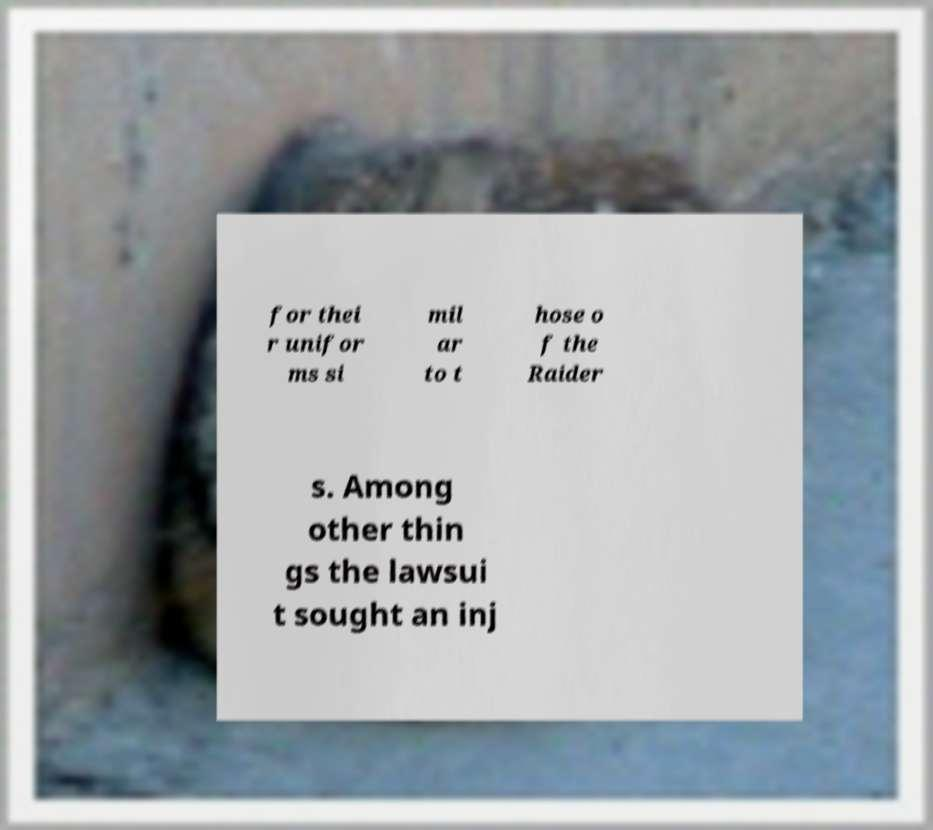For documentation purposes, I need the text within this image transcribed. Could you provide that? for thei r unifor ms si mil ar to t hose o f the Raider s. Among other thin gs the lawsui t sought an inj 